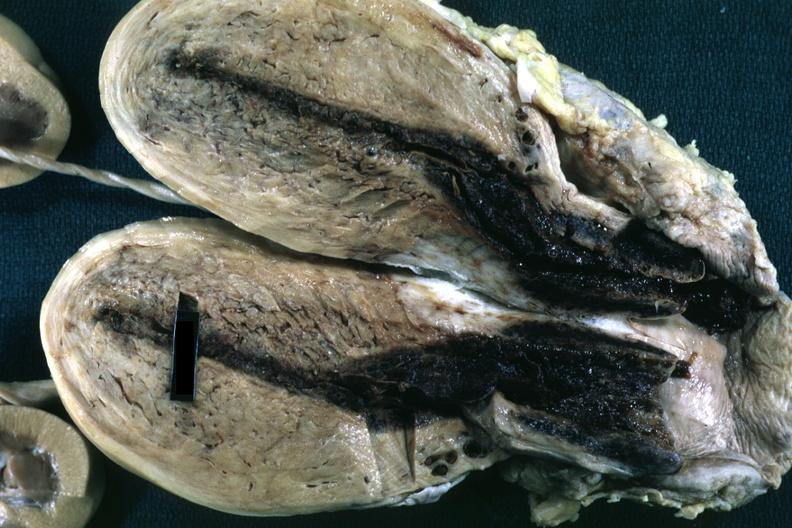what does this image show?
Answer the question using a single word or phrase. Fixed tissue opened uterus with blood clot in cervical canal and small endometrial cavity 